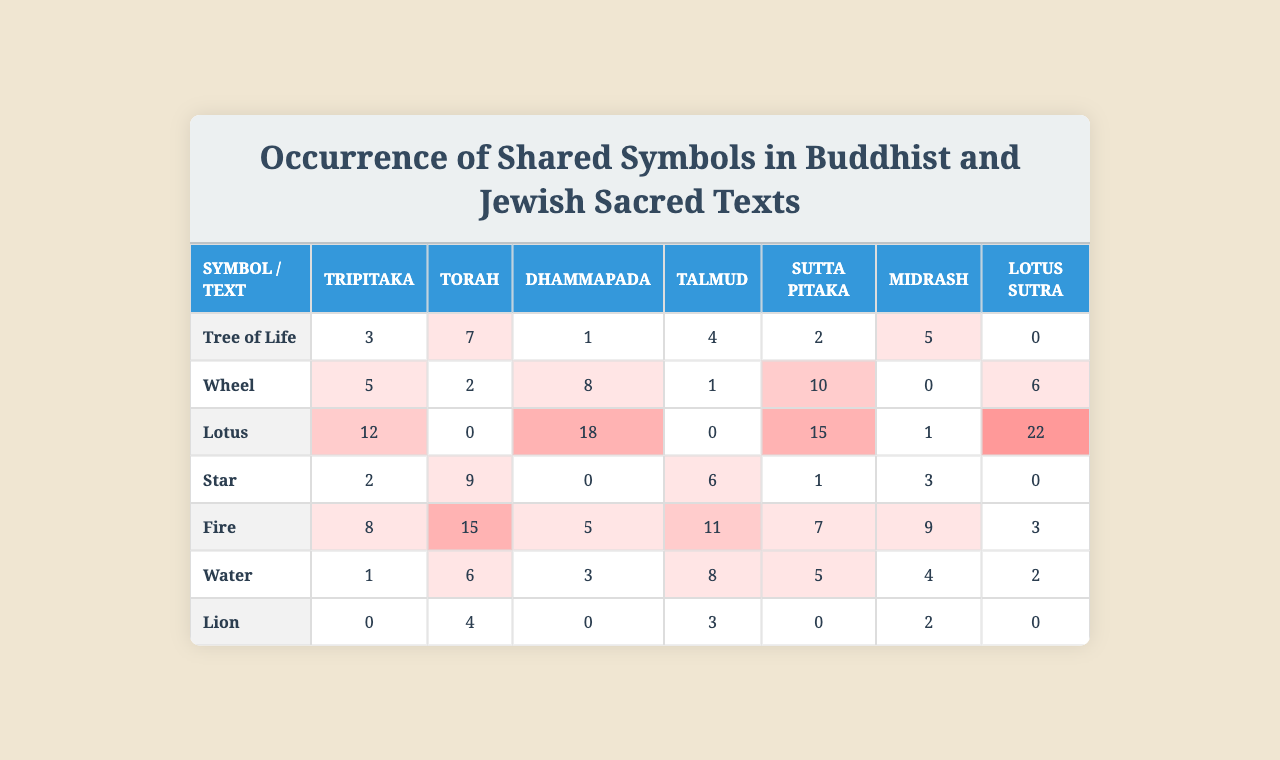What is the occurrence of the "Lotus" symbol in the Torah? From the table, we look at the row for the "Lotus" symbol, which shows the occurrences across different texts. In the Torah column, the value is 0, indicating that the "Lotus" does not appear in the Torah.
Answer: 0 Which text mentions the "Tree of Life" the most? By examining the occurrences of the "Tree of Life" across all texts, we see that the highest number is 12, which appears in the Dhammapada.
Answer: Dhammapada What is the total occurrence of the "Fire" symbol across all texts? The occurrences of the "Fire" symbol are as follows: Tripitaka (8), Torah (15), Dhammapada (5), Talmud (11), Sutta Pitaka (7), Midrash (9), and Lotus Sutra (3). Adding these together gives: 8 + 15 + 5 + 11 + 7 + 9 + 3 = 58.
Answer: 58 Is there any text that mentions the "Lion" symbol more than 5 times? Reviewing the occurrences of the "Lion" symbol, we find values for each text: 0, 4, 0, 3, 0, 2, 0. None of these values exceeds 5, therefore, no text mentions the "Lion" more than 5 times.
Answer: No What is the average occurrence of the "Wheel" symbol across all texts? The occurrences for the "Wheel" symbol are as follows: 5, 9, 0, 6, 1, 3, 6. Adding these values gives us 5 + 9 + 0 + 6 + 1 + 3 + 6 = 30. There are 7 texts, so the average is 30 divided by 7, which is approximately 4.29.
Answer: 4.29 Which symbol has the highest occurrence in the Midrash? Looking at the Midrash column, the occurrences for each symbol are: 1 (Tree of Life), 6 (Wheel), 3 (Lotus), 8 (Star), 5 (Fire), 4 (Water), and 2 (Lion). The highest number here is 8 for the "Star."
Answer: Star How many symbols have their occurrences equal to 0 in the Sutta Pitaka? Checking the Sutta Pitaka occurrences, we find: Tree of Life (2), Wheel (1), Lotus (15), Star (1), Fire (7), Water (5), Lion (0). Only the "Lion" has 0 occurrences, so there is 1 symbol.
Answer: 1 What is the difference in occurrences of the "Water" symbol between the Torah and Dhammapada? The occurrences for "Water" are 6 in the Torah and 3 in the Dhammapada. The difference is 6 - 3 = 3.
Answer: 3 